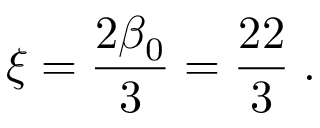Convert formula to latex. <formula><loc_0><loc_0><loc_500><loc_500>\xi = \frac { 2 \beta _ { 0 } } { 3 } = \frac { 2 2 } { 3 } \, .</formula> 